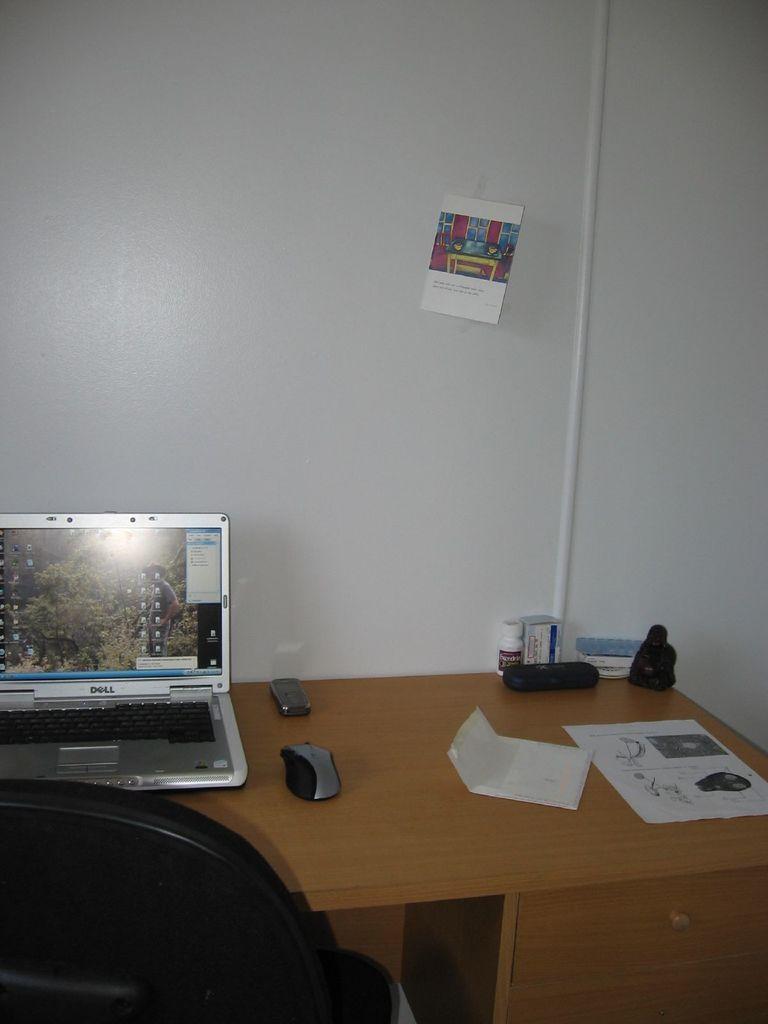How would you summarize this image in a sentence or two? This picture is clicked inside the room. This picture contains a table on which paper, book, mouse, mobile phone, plastic box and laptop are placed. On left bottom of picture, we see a black chair and behind the table, we see white wall on which poster is sticked. 